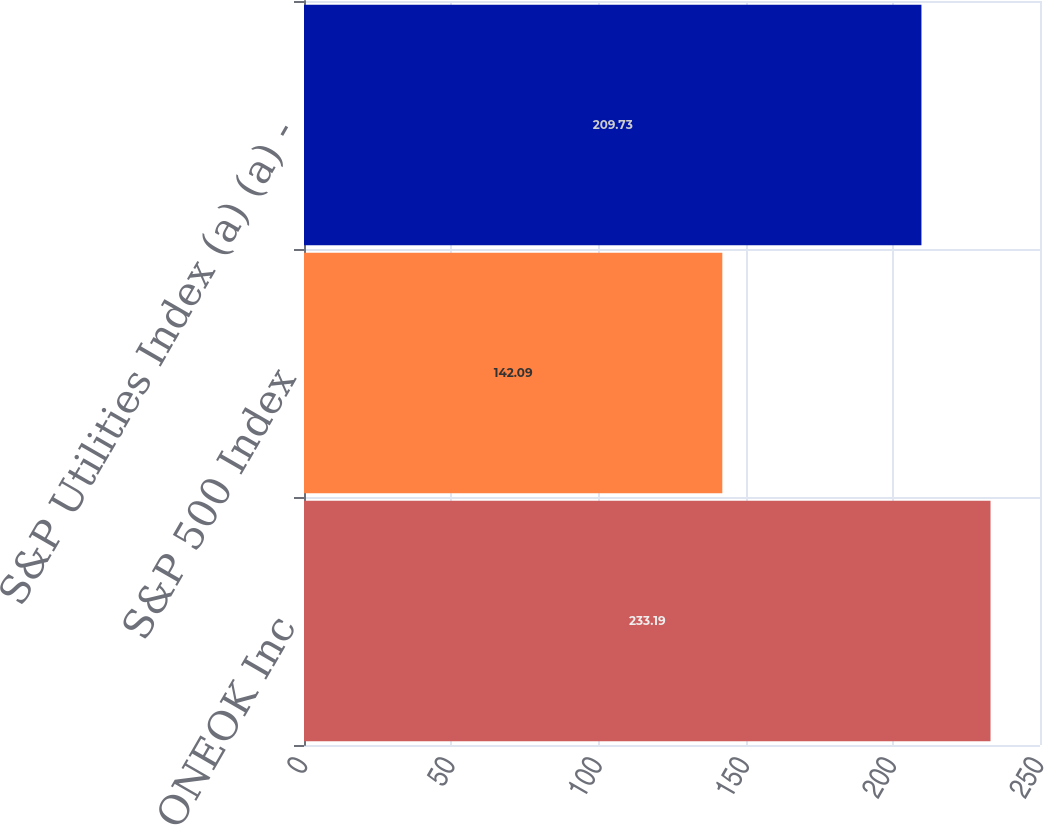Convert chart. <chart><loc_0><loc_0><loc_500><loc_500><bar_chart><fcel>ONEOK Inc<fcel>S&P 500 Index<fcel>S&P Utilities Index (a) (a) -<nl><fcel>233.19<fcel>142.09<fcel>209.73<nl></chart> 